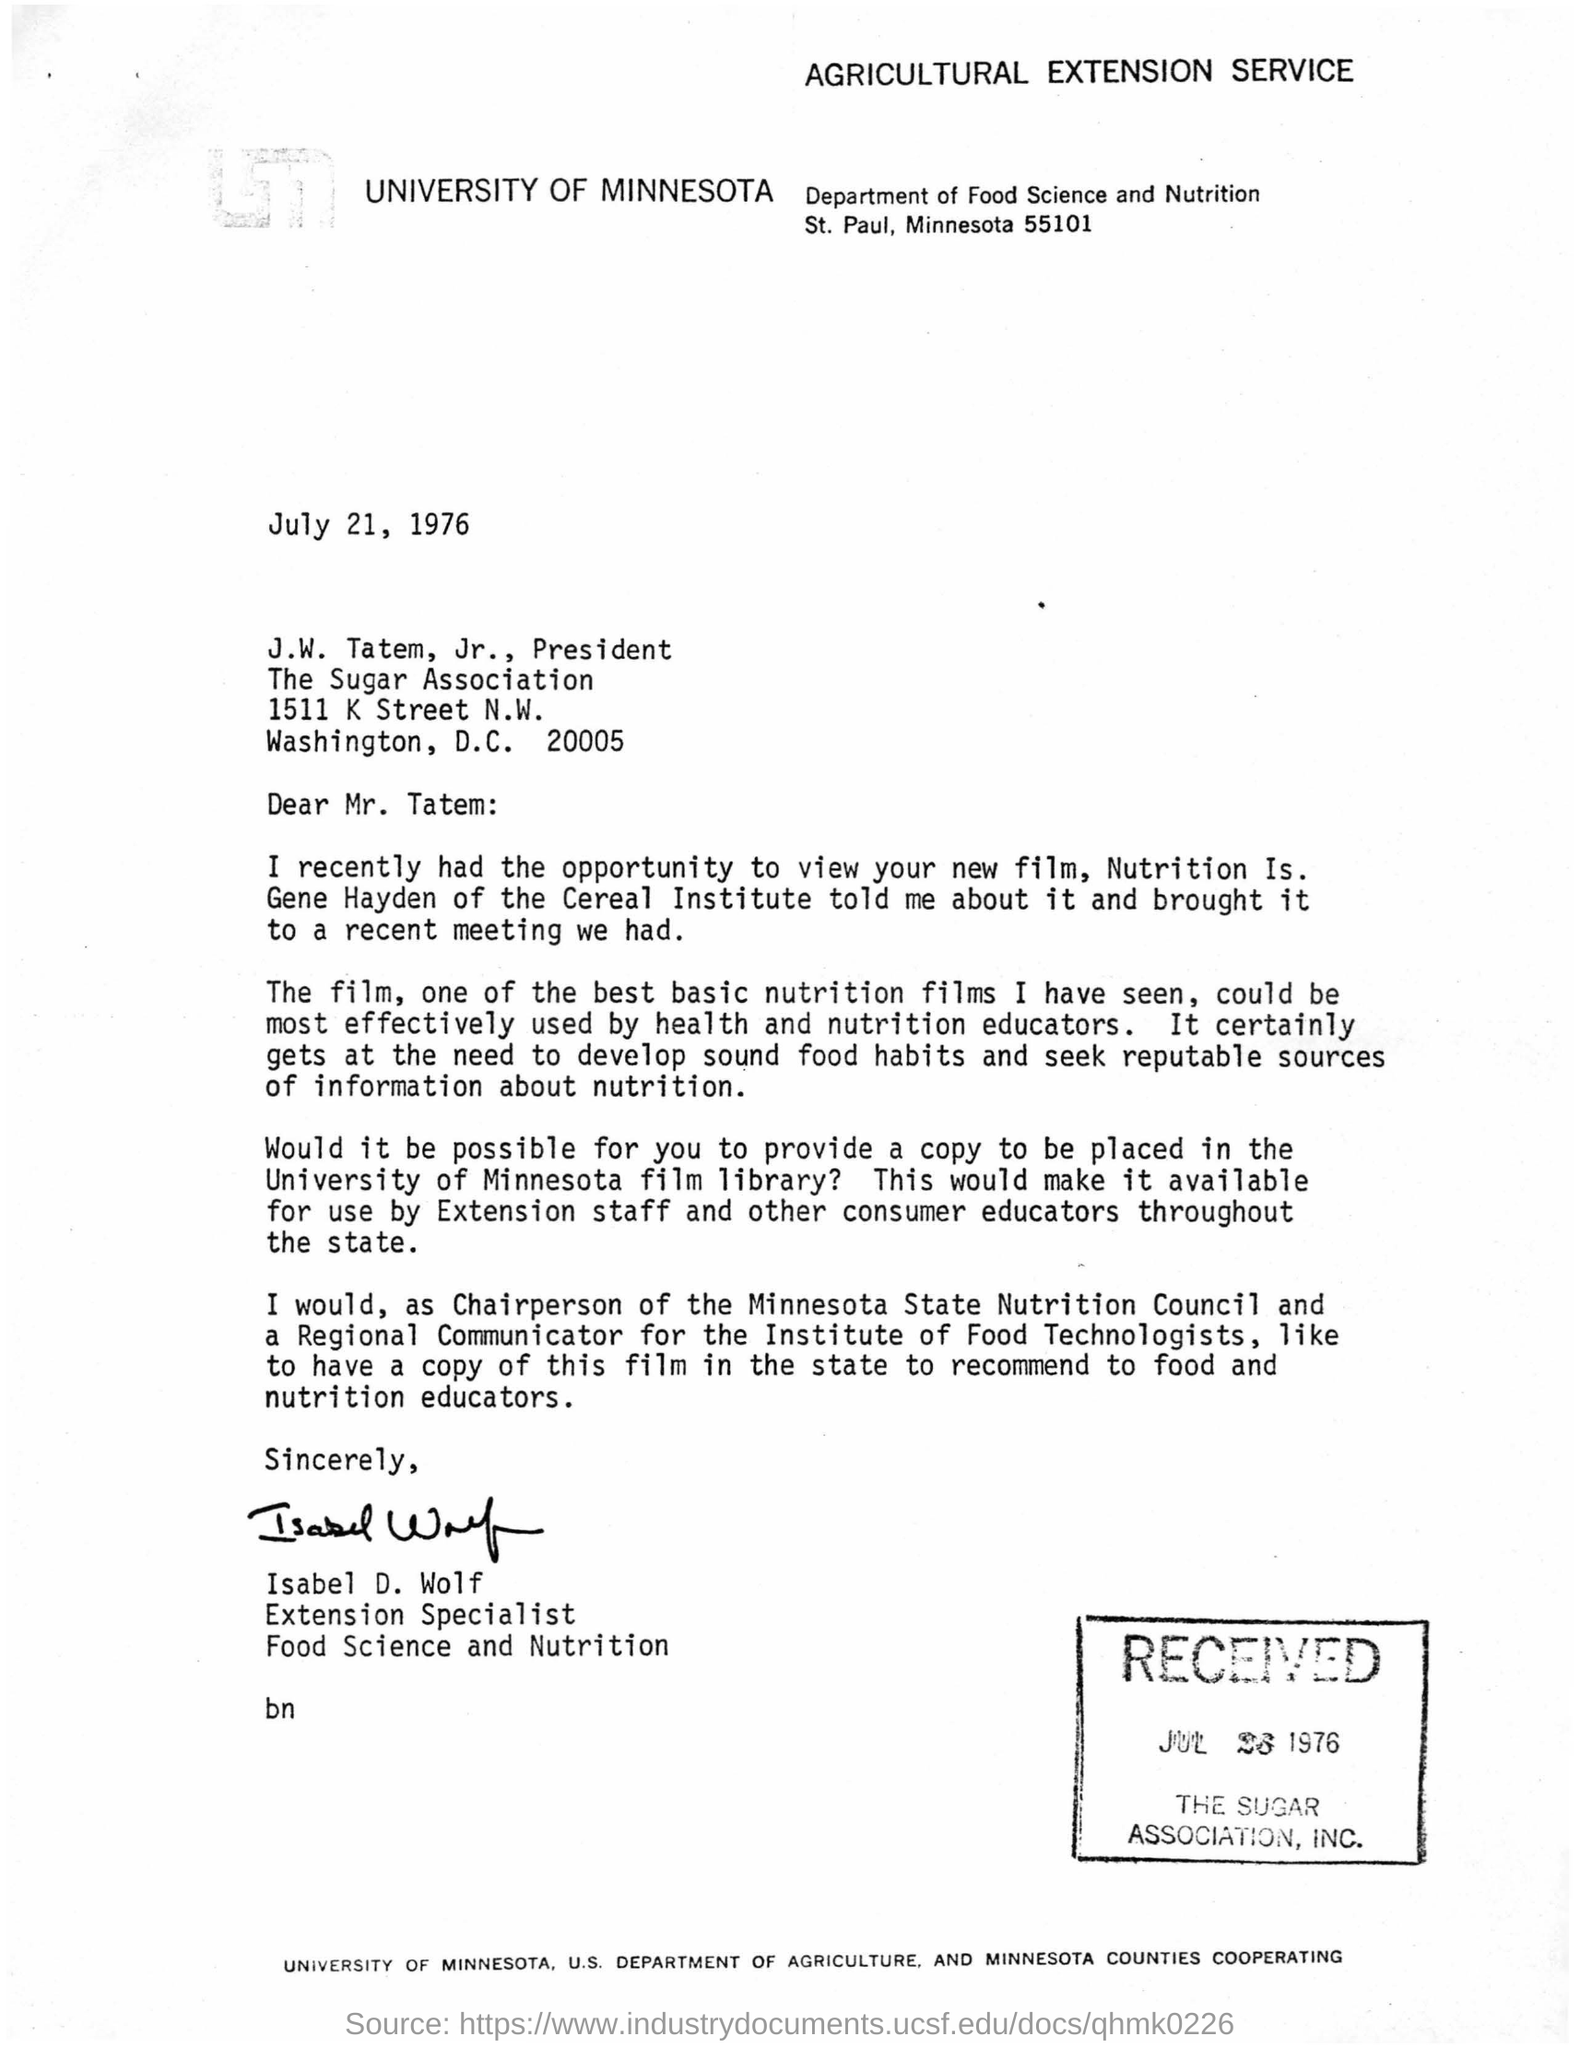Which university wrote the letter?
Provide a short and direct response. University of Minnesota. When was the letter written?
Make the answer very short. July 21, 1976. Who wrote the letter?
Provide a succinct answer. Isabel D. Wolf. 